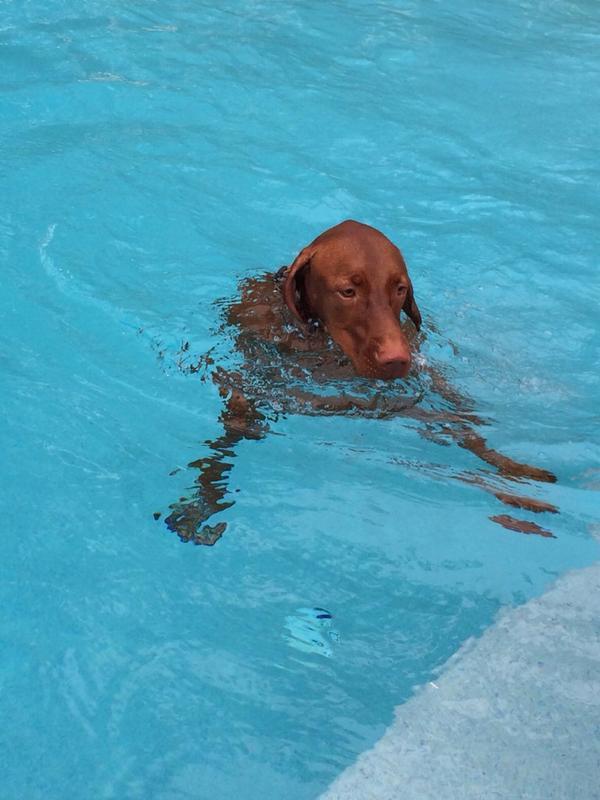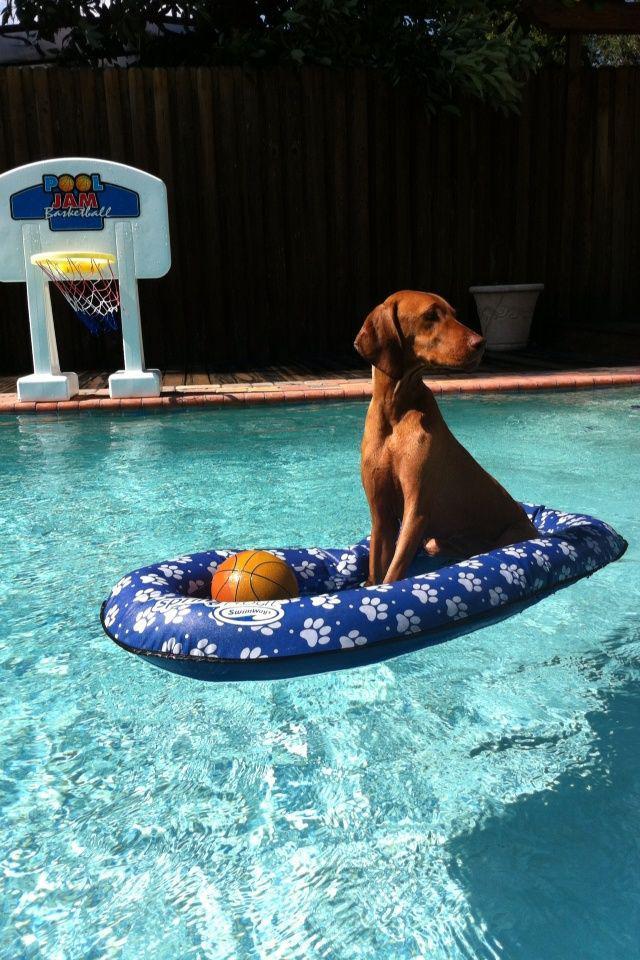The first image is the image on the left, the second image is the image on the right. Examine the images to the left and right. Is the description "One of the dogs is on a blue floating raft and looking to the right." accurate? Answer yes or no. Yes. The first image is the image on the left, the second image is the image on the right. Examine the images to the left and right. Is the description "A dog is leaping into the pool" accurate? Answer yes or no. No. 